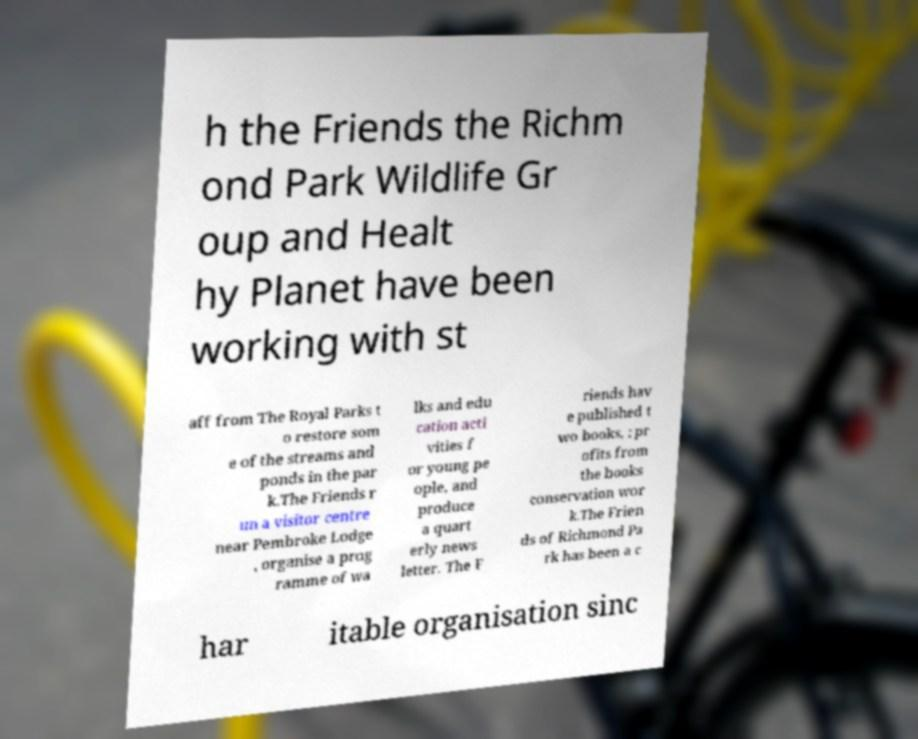Can you accurately transcribe the text from the provided image for me? h the Friends the Richm ond Park Wildlife Gr oup and Healt hy Planet have been working with st aff from The Royal Parks t o restore som e of the streams and ponds in the par k.The Friends r un a visitor centre near Pembroke Lodge , organise a prog ramme of wa lks and edu cation acti vities f or young pe ople, and produce a quart erly news letter. The F riends hav e published t wo books, ; pr ofits from the books conservation wor k.The Frien ds of Richmond Pa rk has been a c har itable organisation sinc 